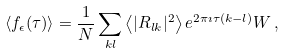Convert formula to latex. <formula><loc_0><loc_0><loc_500><loc_500>\langle f _ { \epsilon } ( \tau ) \rangle = \frac { 1 } { N } \sum _ { k l } \left < | R _ { l k } | ^ { 2 } \right > e ^ { 2 \pi \imath \tau ( k - l ) } W \, ,</formula> 